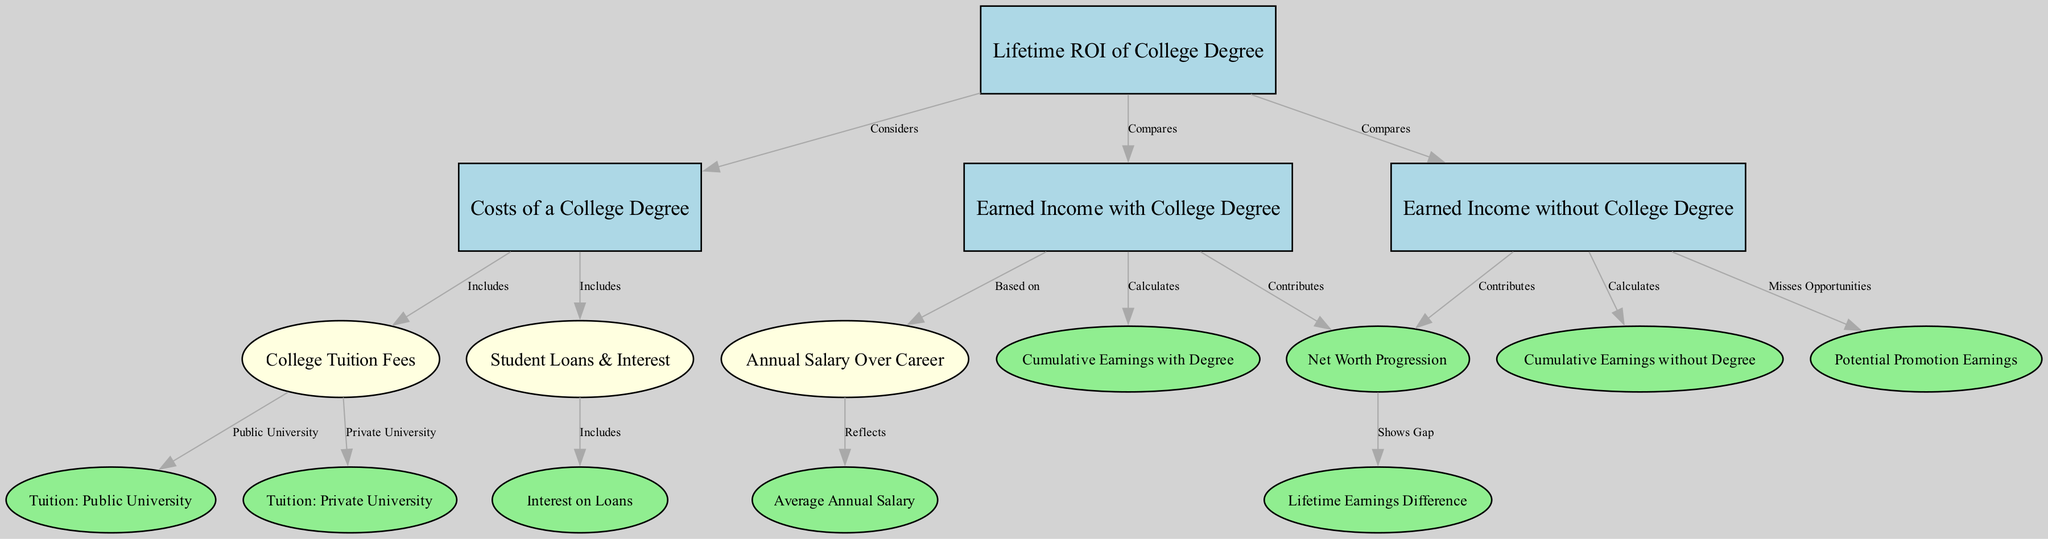What is the title of the diagram? The title of the diagram is explicitly labeled at the top of the diagram, providing a clear overview of the subject matter being addressed.
Answer: Lifetime Financial ROI of a College Degree: Costs vs. Earned Income How many main nodes are present in the diagram? Counting the main nodes, which include nodes that contribute significantly to the primary concept, we find that there are four main nodes: Lifetime ROI of College Degree, Costs of a College Degree, Earned Income with College Degree, and Earned Income without College Degree.
Answer: 4 What type of relationship exists between Earned Income with College Degree and Net Worth Progression? The directed edge from Earned Income with College Degree to Net Worth Progression indicates that Earned Income contributes to Net Worth Progression. This shows a positive relationship between the two.
Answer: Contributes What does the edge between Costs of a College Degree and Tuition: Public University indicate? The edge shows that the Costs of a College Degree includes Tuition: Public University. This indicates that tuition costs are a component of the overall costs associated with obtaining a college degree.
Answer: Includes What is the omitted opportunity indicated between Earned Income without College Degree and Potential Promotion Earnings? The edge connects Earned Income without College Degree to Potential Promotion Earnings and specifies that not having a degree results in missed opportunities for promotions, which can affect lifetime earnings.
Answer: Misses Opportunities What accumulative difference does the diagram suggest between Earned Income with Degree compared to Earned Income without Degree over a lifetime? The edge leading from Net Worth Progression to Lifetime Earnings Difference illustrates that there is a notable gap in earnings that accumulates due to having a college degree compared to not having one throughout a lifetime.
Answer: Shows Gap How are student loans categorized in relation to the overall costs of a college degree? Student Loans & Interest are depicted as a subset of the overall costs, specifically under Costs of a College Degree, indicating that they are significant financial liabilities that need to be accounted for.
Answer: Includes Which factor reflects annual salary over a career in the diagram? The diagram specifies that Annual Salary Over Career is based on Earned Income with College Degree, indicating it reflects financial gains associated with obtaining a degree over time.
Answer: Based on What color are the nodes representing the costs associated with a college degree? The nodes related to costs are styled as ellipses filled with light yellow color, distinguishing them visually from other categories in the diagram.
Answer: Light yellow 